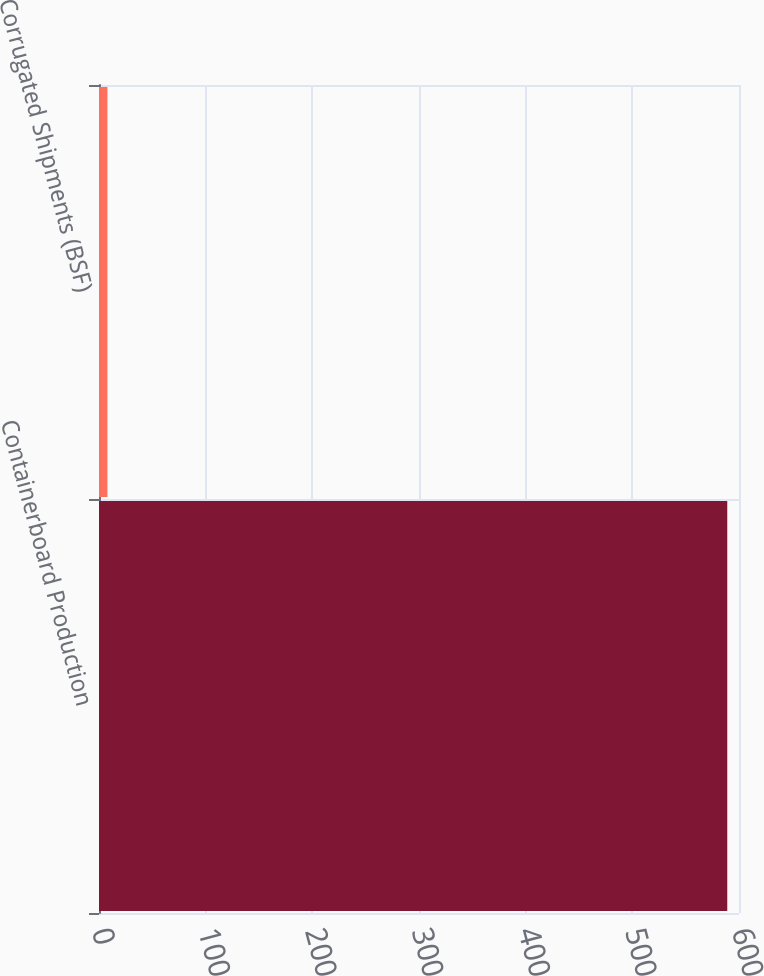Convert chart. <chart><loc_0><loc_0><loc_500><loc_500><bar_chart><fcel>Containerboard Production<fcel>Corrugated Shipments (BSF)<nl><fcel>589<fcel>7.9<nl></chart> 